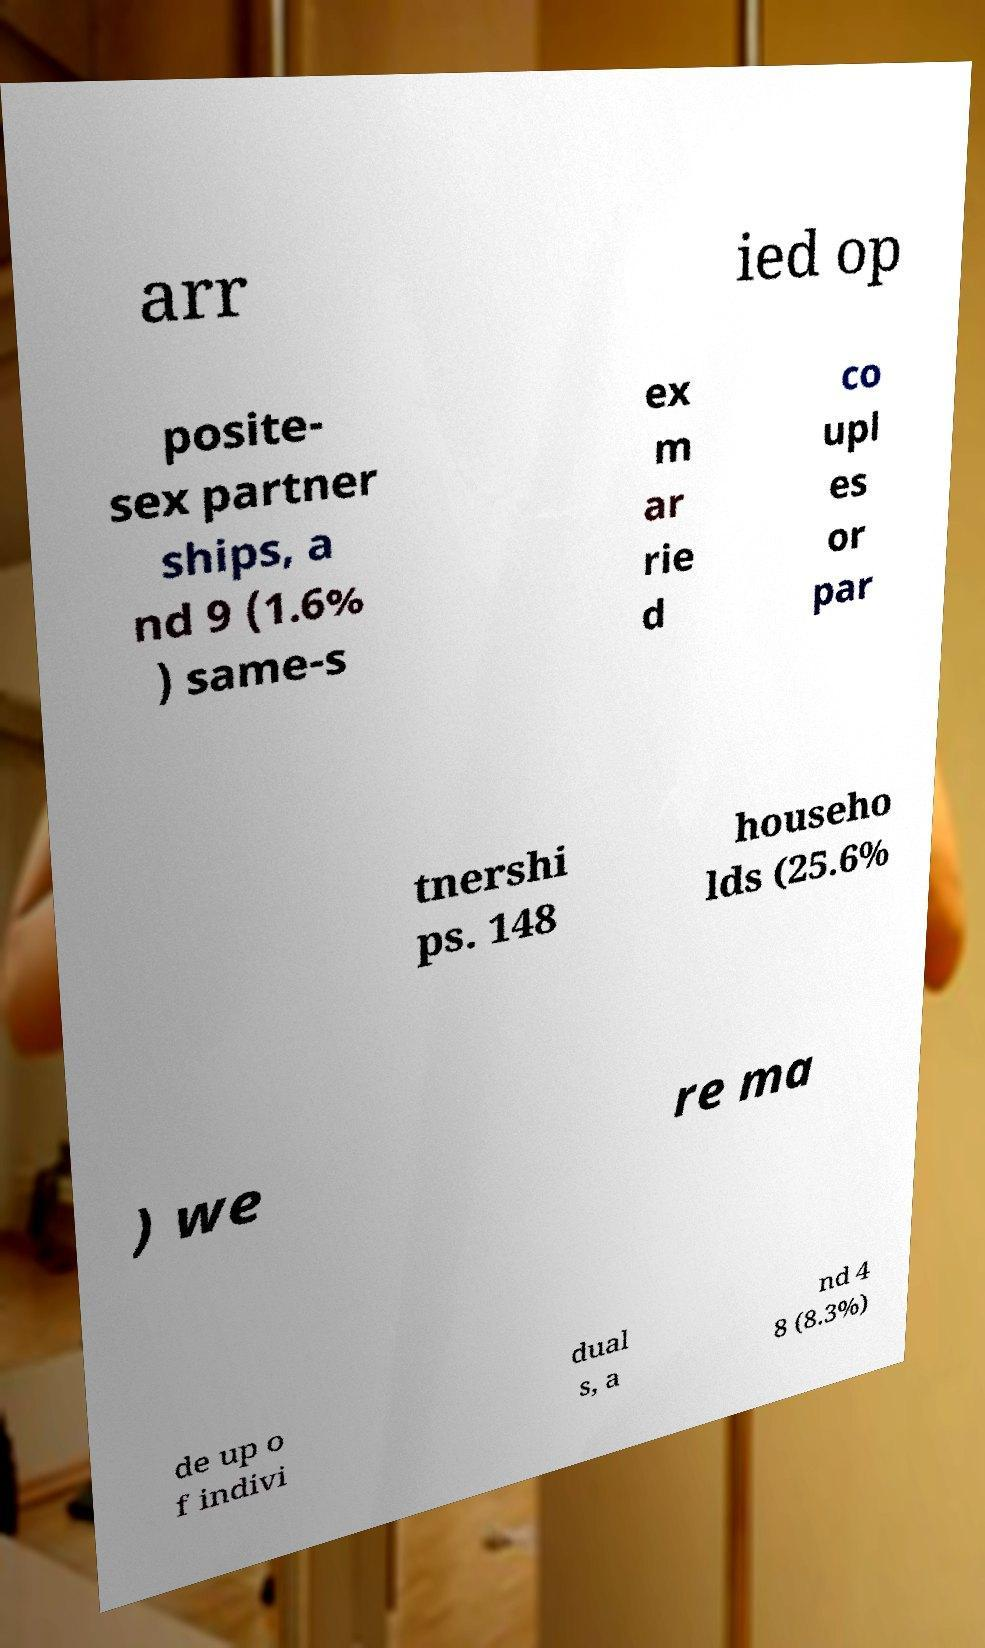Could you extract and type out the text from this image? arr ied op posite- sex partner ships, a nd 9 (1.6% ) same-s ex m ar rie d co upl es or par tnershi ps. 148 househo lds (25.6% ) we re ma de up o f indivi dual s, a nd 4 8 (8.3%) 